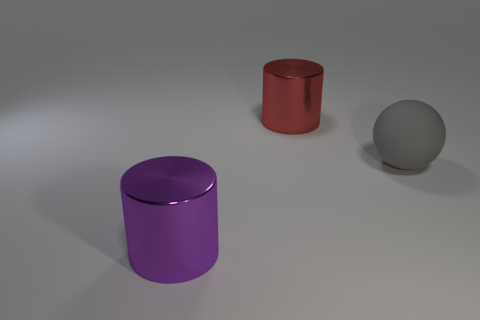Is the number of big objects less than the number of large red metallic objects?
Make the answer very short. No. How many other objects are the same material as the purple object?
Ensure brevity in your answer.  1. Is the material of the large cylinder behind the big purple shiny cylinder the same as the thing that is to the left of the red thing?
Offer a terse response. Yes. Is the number of gray matte objects in front of the large rubber object less than the number of big purple objects?
Your answer should be very brief. Yes. Is there anything else that has the same shape as the big gray thing?
Keep it short and to the point. No. There is another shiny thing that is the same shape as the red object; what color is it?
Keep it short and to the point. Purple. Do the metal cylinder in front of the gray rubber ball and the big rubber sphere have the same size?
Your answer should be compact. Yes. Does the big gray ball have the same material as the red cylinder that is behind the large gray matte thing?
Ensure brevity in your answer.  No. Are there fewer purple cylinders that are on the right side of the big red shiny object than red metal things to the left of the ball?
Provide a short and direct response. Yes. The big thing that is the same material as the large purple cylinder is what color?
Make the answer very short. Red. 